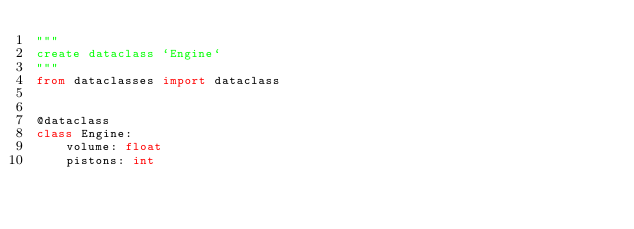<code> <loc_0><loc_0><loc_500><loc_500><_Python_>"""
create dataclass `Engine`
"""
from dataclasses import dataclass


@dataclass
class Engine:
    volume: float
    pistons: int
</code> 